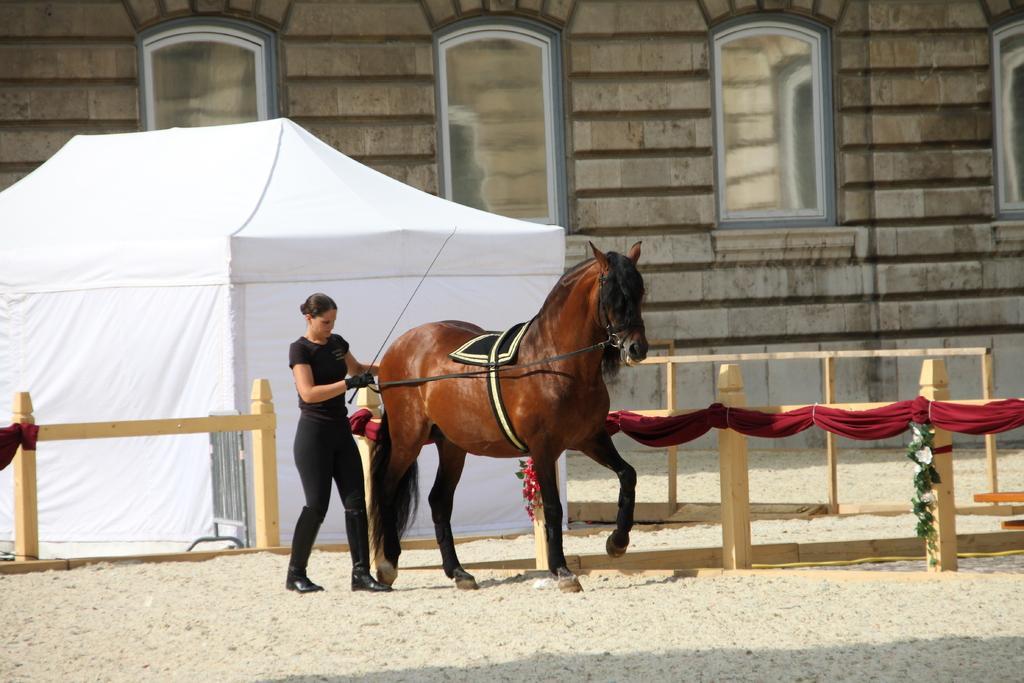Can you describe this image briefly? On the background we can see wall with windows. This is a white colour tent. Here we can see a horse and a woman is holding a belt of this horse. This is a sand. Here we can see wooden fence decorated with flowers and red colour cloth. 